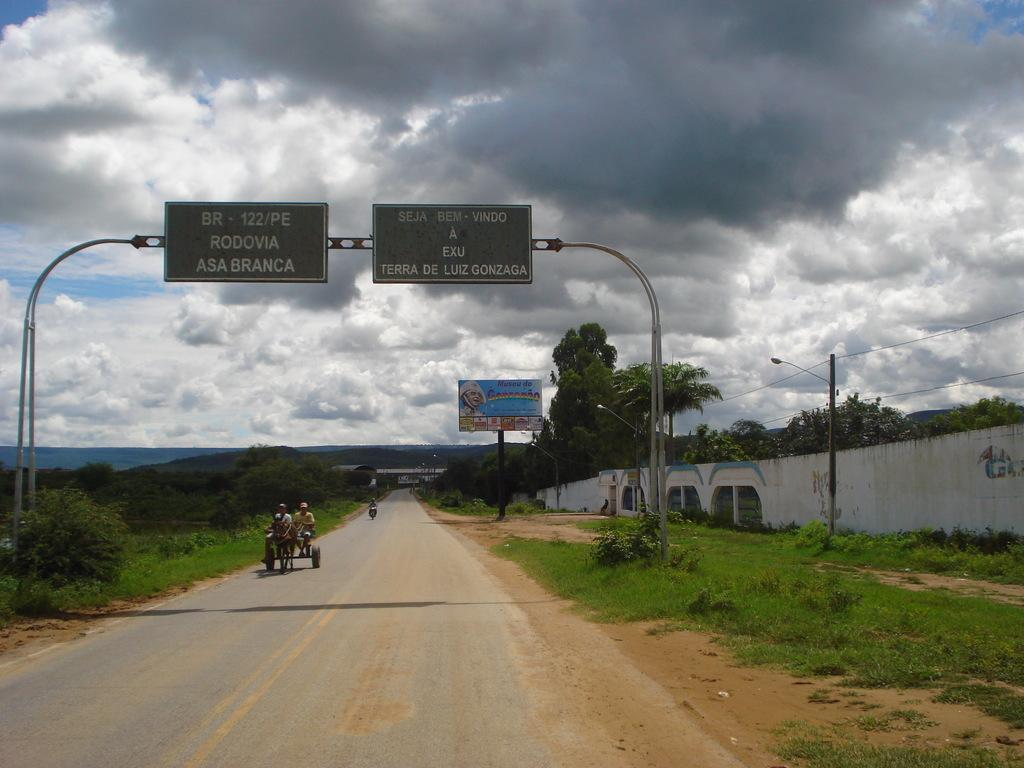<image>
Present a compact description of the photo's key features. People travel by horse drawn carriage down BR- 122/PE 